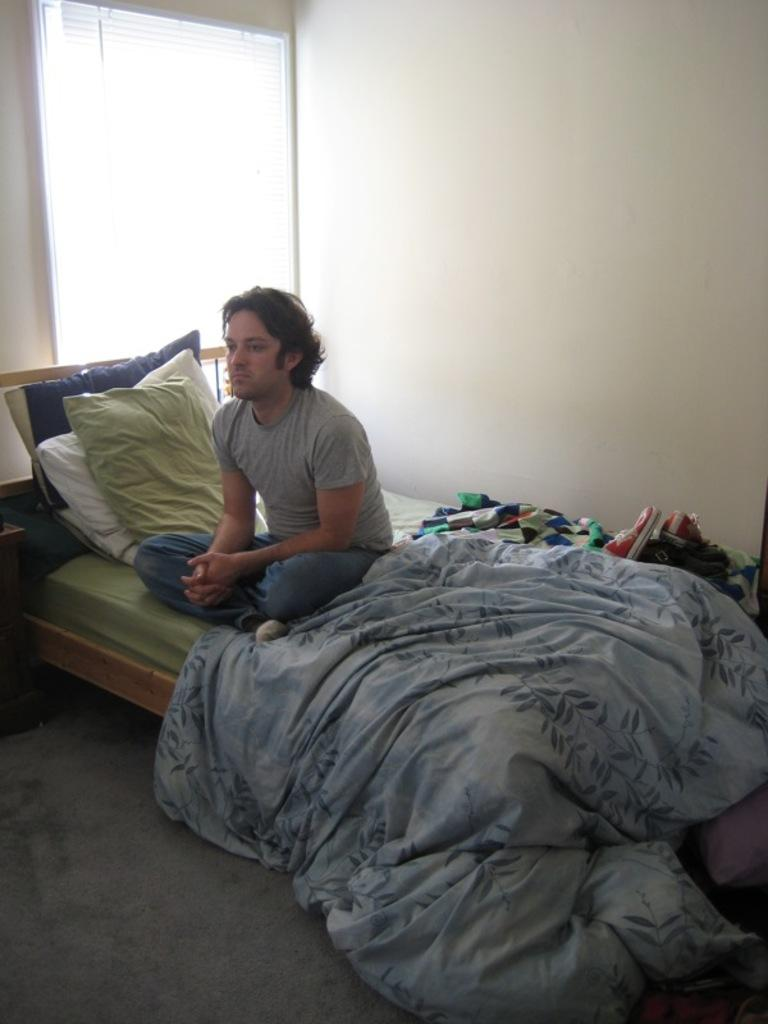What is the person in the image doing? There is a person sitting on the bed. What can be seen on the bed besides the person? There are pillows, a blanket, shoes, and other objects on the bed. What is visible on the wall in the background? There is a blind window in the background. What month is it in the image? The month cannot be determined from the image, as there is no information about the time or date. Can you see the person's elbow in the image? The person's elbow is not visible in the image, as only the upper body and head are shown. 